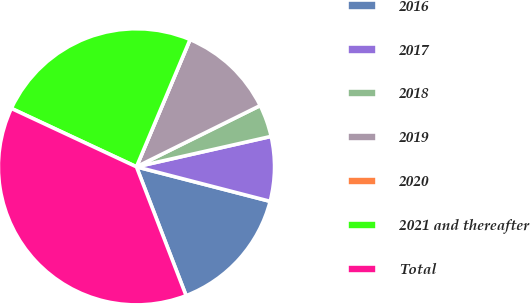Convert chart to OTSL. <chart><loc_0><loc_0><loc_500><loc_500><pie_chart><fcel>2016<fcel>2017<fcel>2018<fcel>2019<fcel>2020<fcel>2021 and thereafter<fcel>Total<nl><fcel>15.12%<fcel>7.56%<fcel>3.78%<fcel>11.34%<fcel>0.0%<fcel>24.39%<fcel>37.8%<nl></chart> 